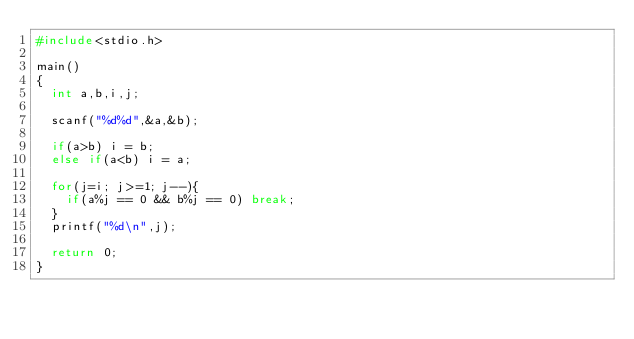Convert code to text. <code><loc_0><loc_0><loc_500><loc_500><_C_>#include<stdio.h>

main()
{
  int a,b,i,j;

  scanf("%d%d",&a,&b);

  if(a>b) i = b;
  else if(a<b) i = a;

  for(j=i; j>=1; j--){
    if(a%j == 0 && b%j == 0) break;
  }
  printf("%d\n",j);

  return 0;
}</code> 